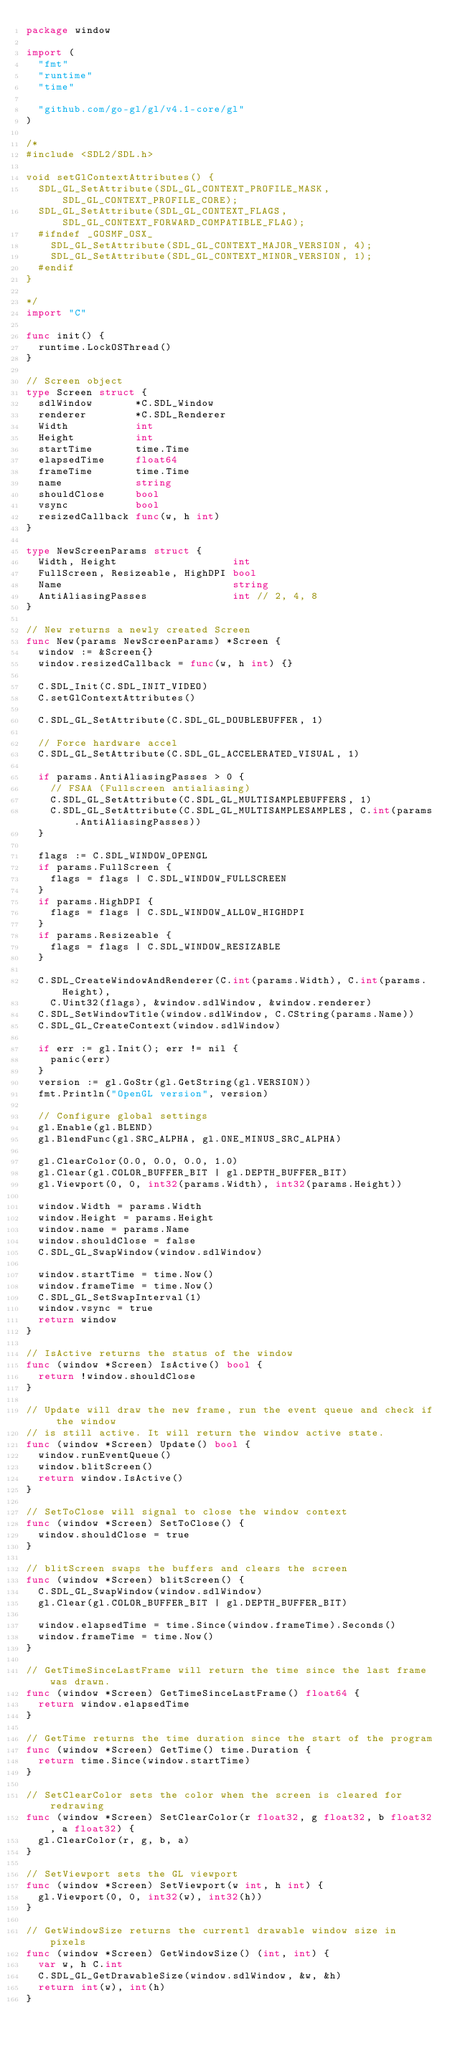<code> <loc_0><loc_0><loc_500><loc_500><_Go_>package window

import (
	"fmt"
	"runtime"
	"time"

	"github.com/go-gl/gl/v4.1-core/gl"
)

/*
#include <SDL2/SDL.h>

void setGlContextAttributes() {
	SDL_GL_SetAttribute(SDL_GL_CONTEXT_PROFILE_MASK, SDL_GL_CONTEXT_PROFILE_CORE);
	SDL_GL_SetAttribute(SDL_GL_CONTEXT_FLAGS, SDL_GL_CONTEXT_FORWARD_COMPATIBLE_FLAG);
	#ifndef _GOSMF_OSX_
		SDL_GL_SetAttribute(SDL_GL_CONTEXT_MAJOR_VERSION, 4);
		SDL_GL_SetAttribute(SDL_GL_CONTEXT_MINOR_VERSION, 1);
	#endif
}

*/
import "C"

func init() {
	runtime.LockOSThread()
}

// Screen object
type Screen struct {
	sdlWindow       *C.SDL_Window
	renderer        *C.SDL_Renderer
	Width           int
	Height          int
	startTime       time.Time
	elapsedTime     float64
	frameTime       time.Time
	name            string
	shouldClose     bool
	vsync           bool
	resizedCallback func(w, h int)
}

type NewScreenParams struct {
	Width, Height                   int
	FullScreen, Resizeable, HighDPI bool
	Name                            string
	AntiAliasingPasses              int // 2, 4, 8
}

// New returns a newly created Screen
func New(params NewScreenParams) *Screen {
	window := &Screen{}
	window.resizedCallback = func(w, h int) {}

	C.SDL_Init(C.SDL_INIT_VIDEO)
	C.setGlContextAttributes()

	C.SDL_GL_SetAttribute(C.SDL_GL_DOUBLEBUFFER, 1)

	// Force hardware accel
	C.SDL_GL_SetAttribute(C.SDL_GL_ACCELERATED_VISUAL, 1)

	if params.AntiAliasingPasses > 0 {
		// FSAA (Fullscreen antialiasing)
		C.SDL_GL_SetAttribute(C.SDL_GL_MULTISAMPLEBUFFERS, 1)
		C.SDL_GL_SetAttribute(C.SDL_GL_MULTISAMPLESAMPLES, C.int(params.AntiAliasingPasses))
	}

	flags := C.SDL_WINDOW_OPENGL
	if params.FullScreen {
		flags = flags | C.SDL_WINDOW_FULLSCREEN
	}
	if params.HighDPI {
		flags = flags | C.SDL_WINDOW_ALLOW_HIGHDPI
	}
	if params.Resizeable {
		flags = flags | C.SDL_WINDOW_RESIZABLE
	}

	C.SDL_CreateWindowAndRenderer(C.int(params.Width), C.int(params.Height),
		C.Uint32(flags), &window.sdlWindow, &window.renderer)
	C.SDL_SetWindowTitle(window.sdlWindow, C.CString(params.Name))
	C.SDL_GL_CreateContext(window.sdlWindow)

	if err := gl.Init(); err != nil {
		panic(err)
	}
	version := gl.GoStr(gl.GetString(gl.VERSION))
	fmt.Println("OpenGL version", version)

	// Configure global settings
	gl.Enable(gl.BLEND)
	gl.BlendFunc(gl.SRC_ALPHA, gl.ONE_MINUS_SRC_ALPHA)

	gl.ClearColor(0.0, 0.0, 0.0, 1.0)
	gl.Clear(gl.COLOR_BUFFER_BIT | gl.DEPTH_BUFFER_BIT)
	gl.Viewport(0, 0, int32(params.Width), int32(params.Height))

	window.Width = params.Width
	window.Height = params.Height
	window.name = params.Name
	window.shouldClose = false
	C.SDL_GL_SwapWindow(window.sdlWindow)

	window.startTime = time.Now()
	window.frameTime = time.Now()
	C.SDL_GL_SetSwapInterval(1)
	window.vsync = true
	return window
}

// IsActive returns the status of the window
func (window *Screen) IsActive() bool {
	return !window.shouldClose
}

// Update will draw the new frame, run the event queue and check if the window
// is still active. It will return the window active state.
func (window *Screen) Update() bool {
	window.runEventQueue()
	window.blitScreen()
	return window.IsActive()
}

// SetToClose will signal to close the window context
func (window *Screen) SetToClose() {
	window.shouldClose = true
}

// blitScreen swaps the buffers and clears the screen
func (window *Screen) blitScreen() {
	C.SDL_GL_SwapWindow(window.sdlWindow)
	gl.Clear(gl.COLOR_BUFFER_BIT | gl.DEPTH_BUFFER_BIT)

	window.elapsedTime = time.Since(window.frameTime).Seconds()
	window.frameTime = time.Now()
}

// GetTimeSinceLastFrame will return the time since the last frame was drawn.
func (window *Screen) GetTimeSinceLastFrame() float64 {
	return window.elapsedTime
}

// GetTime returns the time duration since the start of the program
func (window *Screen) GetTime() time.Duration {
	return time.Since(window.startTime)
}

// SetClearColor sets the color when the screen is cleared for redrawing
func (window *Screen) SetClearColor(r float32, g float32, b float32, a float32) {
	gl.ClearColor(r, g, b, a)
}

// SetViewport sets the GL viewport
func (window *Screen) SetViewport(w int, h int) {
	gl.Viewport(0, 0, int32(w), int32(h))
}

// GetWindowSize returns the currentl drawable window size in pixels
func (window *Screen) GetWindowSize() (int, int) {
	var w, h C.int
	C.SDL_GL_GetDrawableSize(window.sdlWindow, &w, &h)
	return int(w), int(h)
}
</code> 